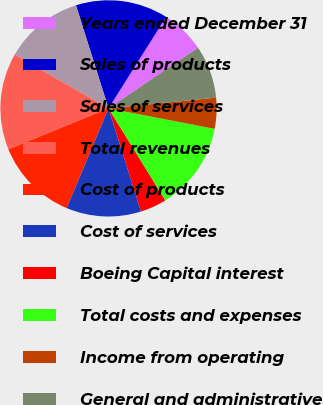Convert chart. <chart><loc_0><loc_0><loc_500><loc_500><pie_chart><fcel>Years ended December 31<fcel>Sales of products<fcel>Sales of services<fcel>Total revenues<fcel>Cost of products<fcel>Cost of services<fcel>Boeing Capital interest<fcel>Total costs and expenses<fcel>Income from operating<fcel>General and administrative<nl><fcel>6.58%<fcel>13.82%<fcel>11.84%<fcel>14.47%<fcel>12.5%<fcel>11.18%<fcel>3.95%<fcel>13.16%<fcel>4.61%<fcel>7.89%<nl></chart> 